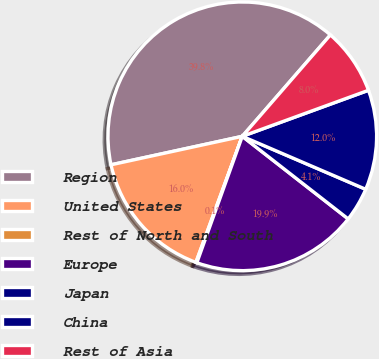Convert chart to OTSL. <chart><loc_0><loc_0><loc_500><loc_500><pie_chart><fcel>Region<fcel>United States<fcel>Rest of North and South<fcel>Europe<fcel>Japan<fcel>China<fcel>Rest of Asia<nl><fcel>39.79%<fcel>15.99%<fcel>0.12%<fcel>19.95%<fcel>4.09%<fcel>12.02%<fcel>8.05%<nl></chart> 